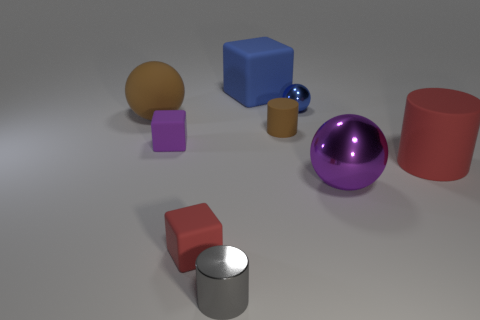Add 1 small gray objects. How many objects exist? 10 Subtract all blocks. How many objects are left? 6 Subtract all purple matte cubes. Subtract all small red cubes. How many objects are left? 7 Add 5 red cylinders. How many red cylinders are left? 6 Add 8 large metallic balls. How many large metallic balls exist? 9 Subtract 1 purple blocks. How many objects are left? 8 